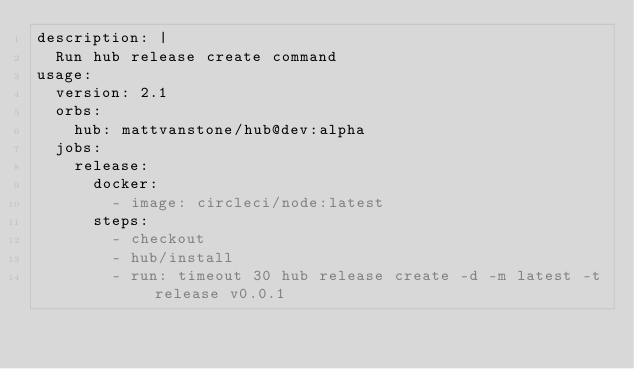Convert code to text. <code><loc_0><loc_0><loc_500><loc_500><_YAML_>description: |
  Run hub release create command
usage:
  version: 2.1
  orbs:
    hub: mattvanstone/hub@dev:alpha
  jobs:
    release:
      docker:
        - image: circleci/node:latest
      steps:
        - checkout
        - hub/install
        - run: timeout 30 hub release create -d -m latest -t release v0.0.1
</code> 